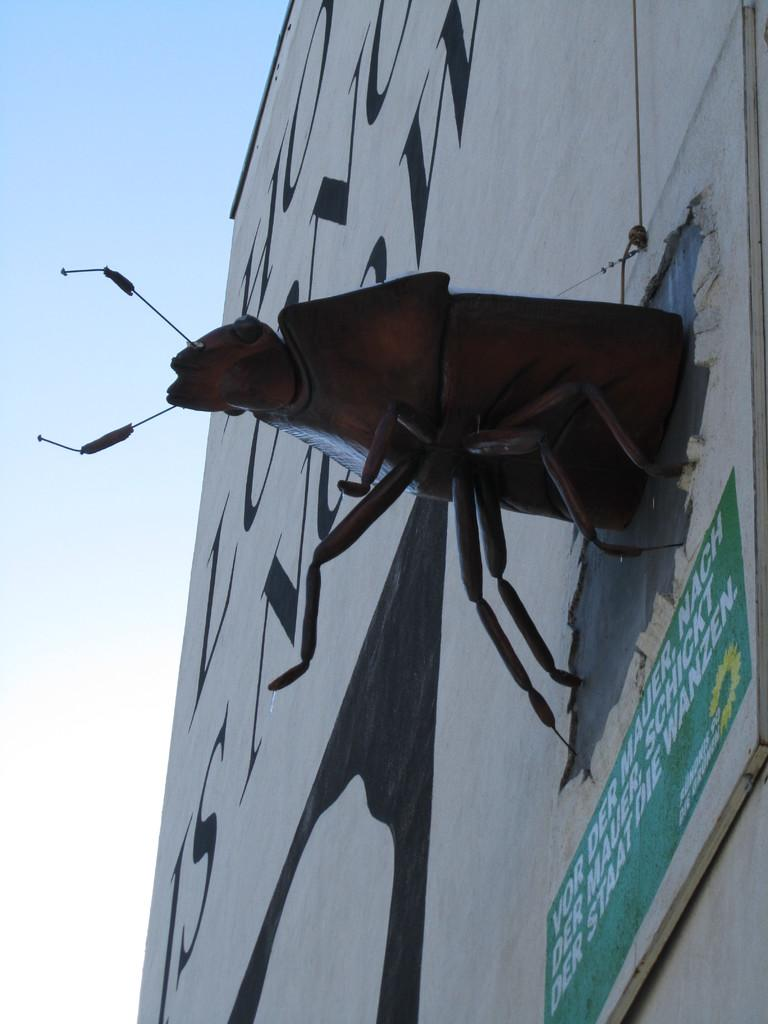What is on the wall in the image? There is a wall with text in the image, and a statue attached to it. What else can be seen with text in the image? There is a board with text in the image. What can be seen in the background of the image? The sky is visible in the background of the image. What type of grain is being harvested in the image? There is no grain or harvesting activity present in the image. Is there a scarf draped over the statue in the image? There is no scarf visible in the image; only the statue and text on the wall and board are present. 